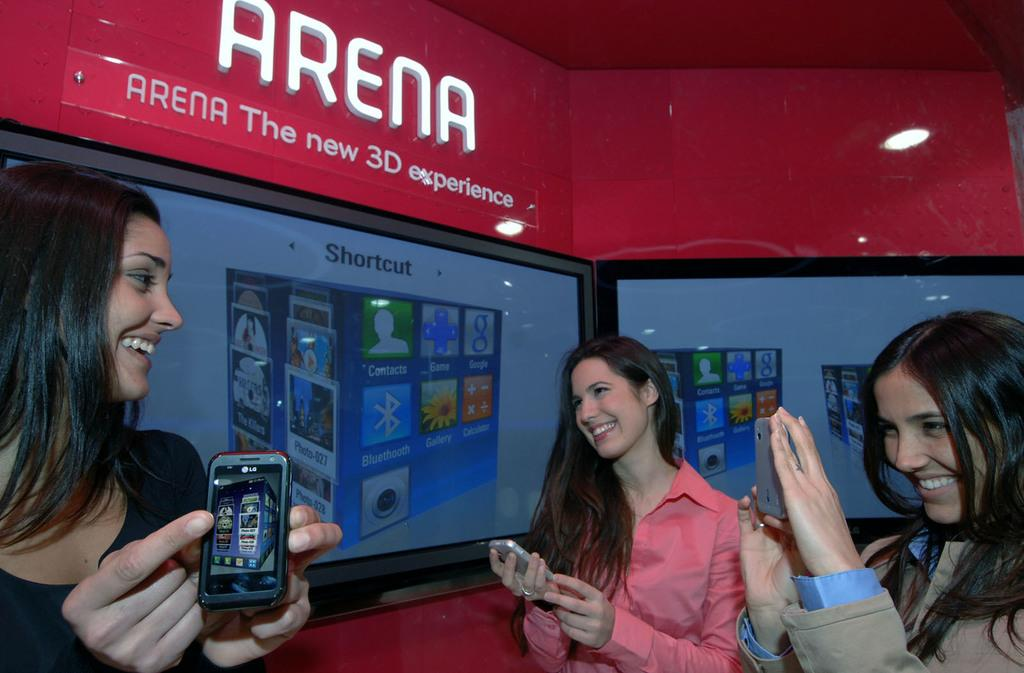How many women are present in the image? There are three women in the image. What are the women holding in their hands? The women are holding mobiles in their hands. What is the facial expression of the women in the image? The women are smiling. What can be seen in the background of the image? There are screens visible in the background of the image. Can you see the women's breath in the image? There is no indication of breath visible in the image. Are there any worms present in the image? There are no worms present in the image. 